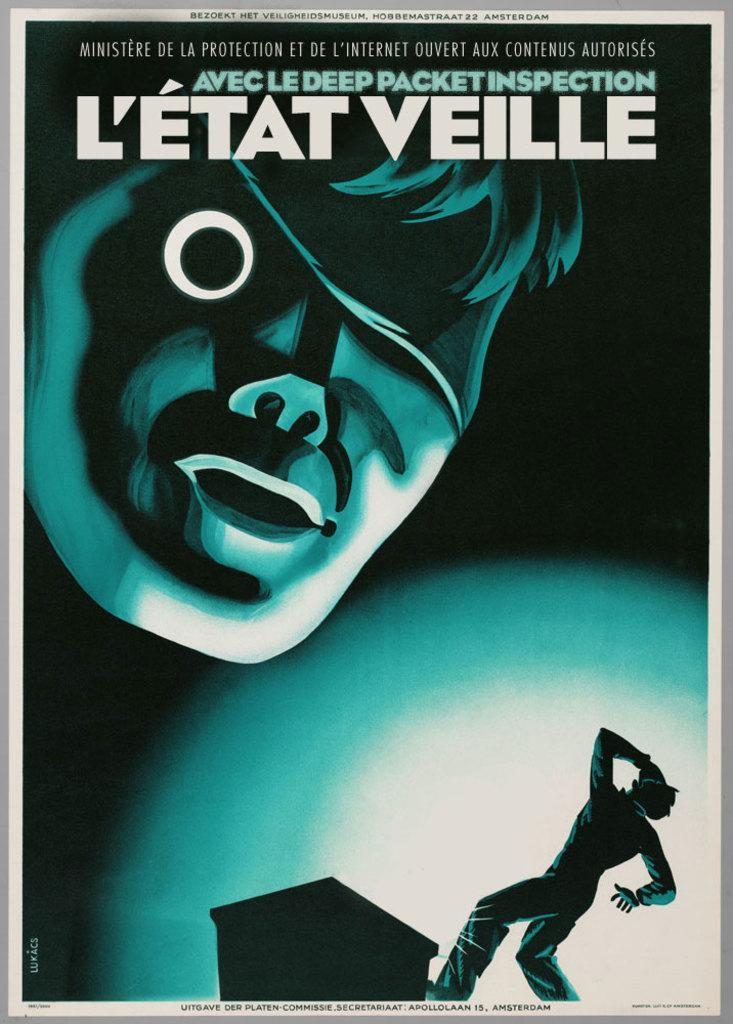How would you summarize this image in a sentence or two? In this picture I can see an animated picture and I can see text at the top and bottom of the picture and I can see couple of cartoons. 